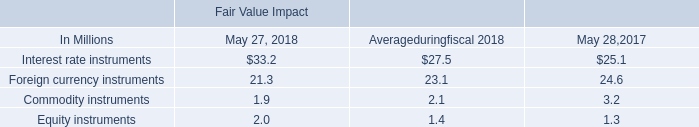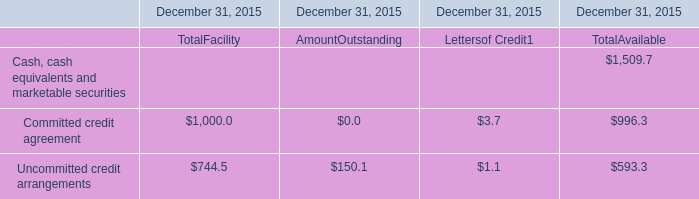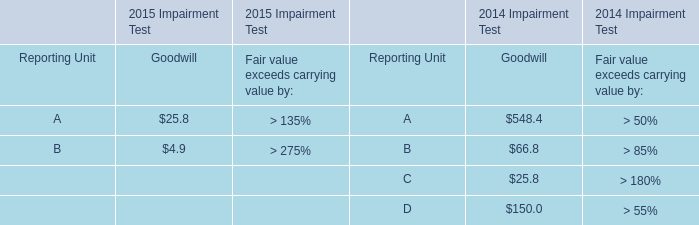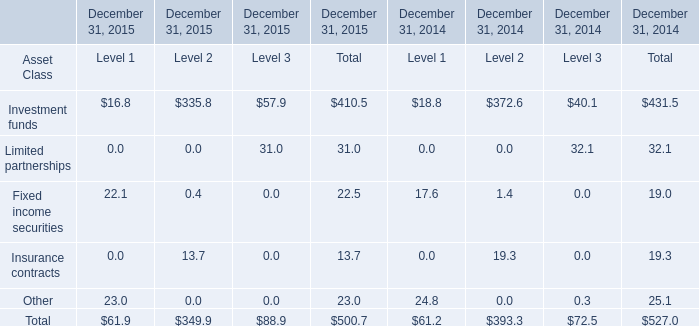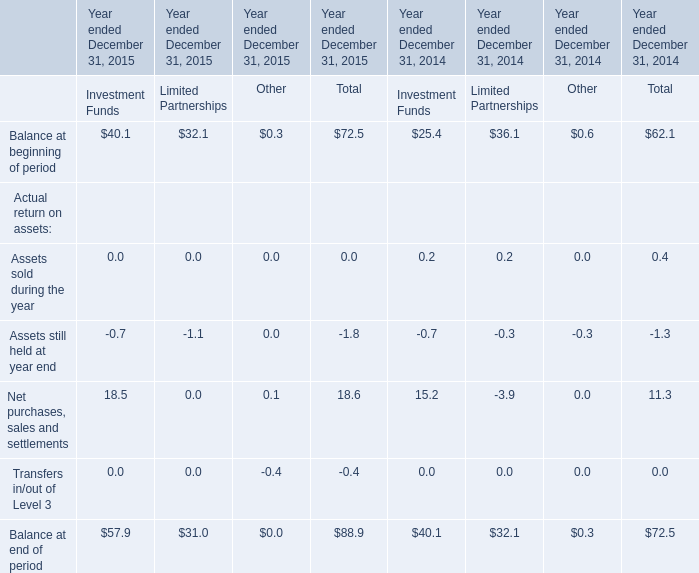What is the sum of elements for Level 1 in 2015? 
Computations: ((((16.8 + 0) + 22.1) + 0) + 23)
Answer: 61.9. 